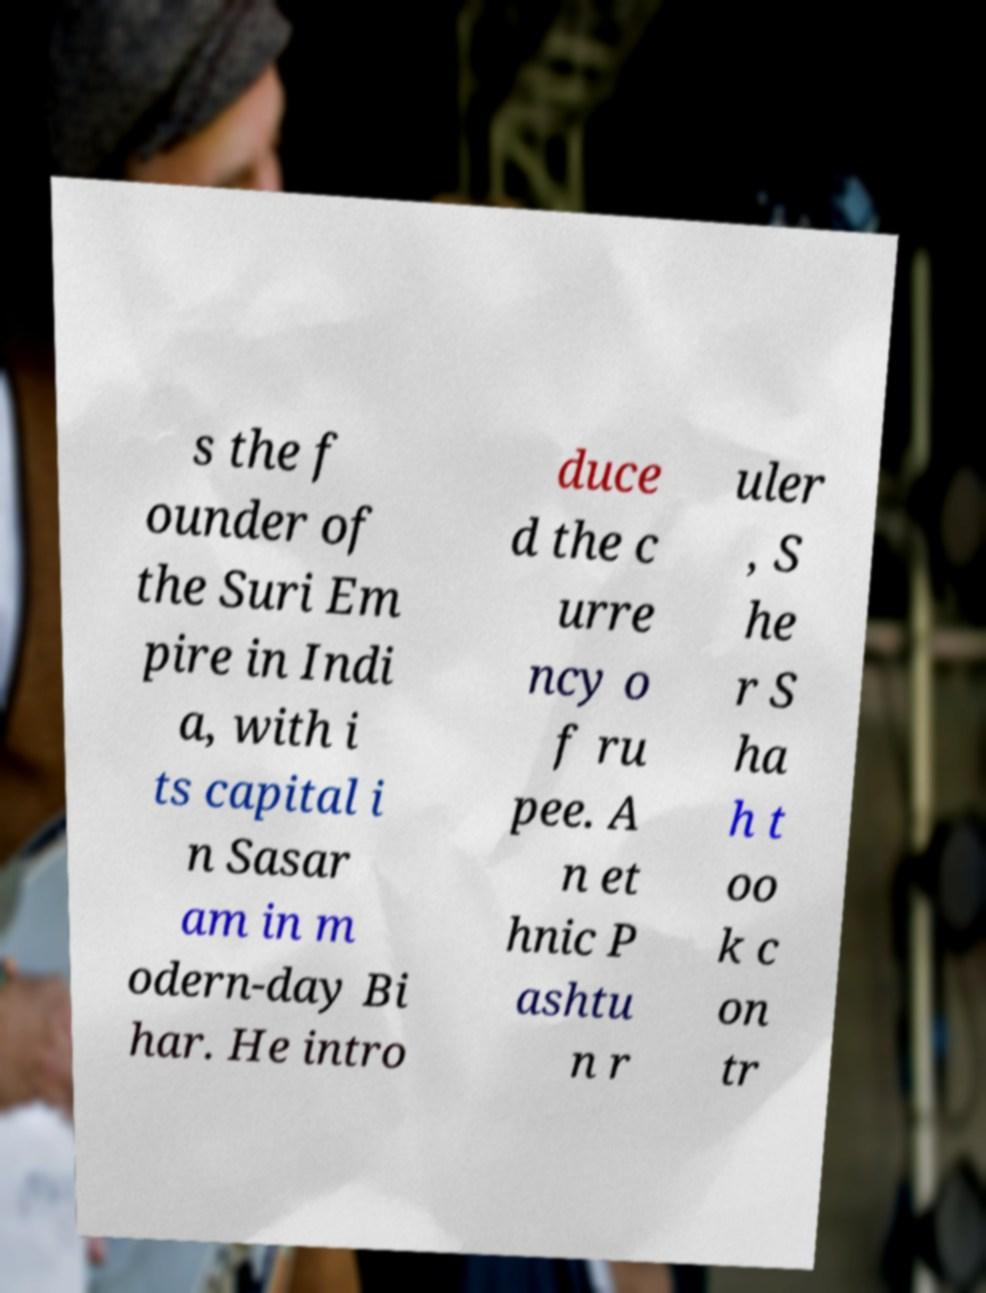Can you read and provide the text displayed in the image?This photo seems to have some interesting text. Can you extract and type it out for me? s the f ounder of the Suri Em pire in Indi a, with i ts capital i n Sasar am in m odern-day Bi har. He intro duce d the c urre ncy o f ru pee. A n et hnic P ashtu n r uler , S he r S ha h t oo k c on tr 